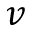Convert formula to latex. <formula><loc_0><loc_0><loc_500><loc_500>v</formula> 